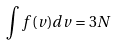Convert formula to latex. <formula><loc_0><loc_0><loc_500><loc_500>\int f ( v ) d v = 3 N</formula> 